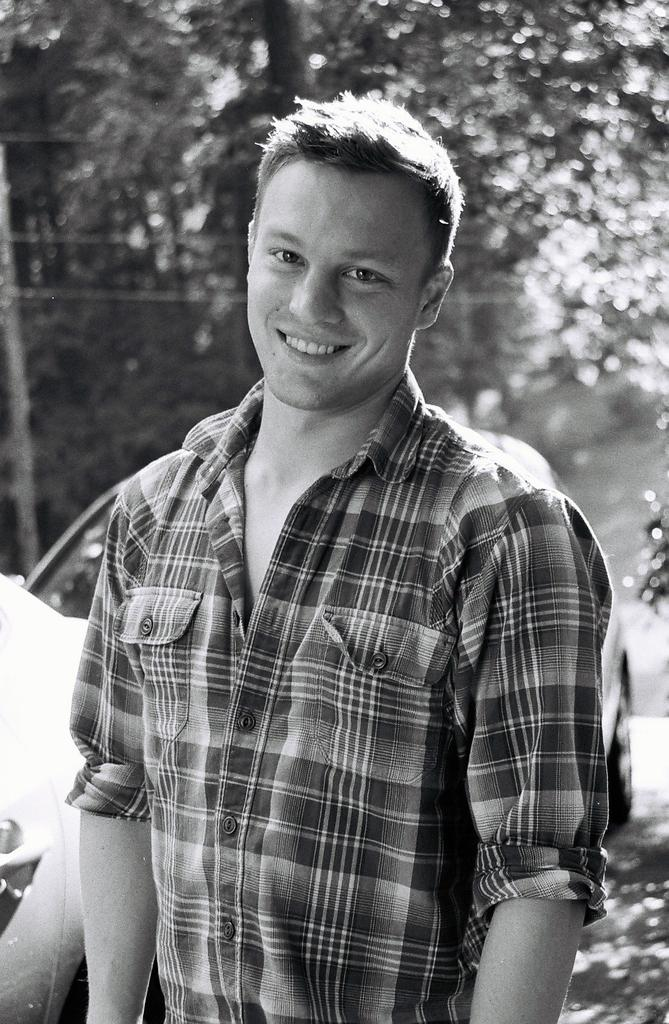What is happening in the image? There are people standing in the image. How are the people in the image feeling? The people are smiling. What can be seen in the background of the image? There are trees visible in the background of the image. What is the color scheme of the image? The image is in black and white. What type of mine is visible in the image? There is no mine present in the image; it features people standing and smiling with trees in the background. What month is it in the image? The image does not provide any information about the month; it is in black and white and features people standing and smiling with trees in the background. 